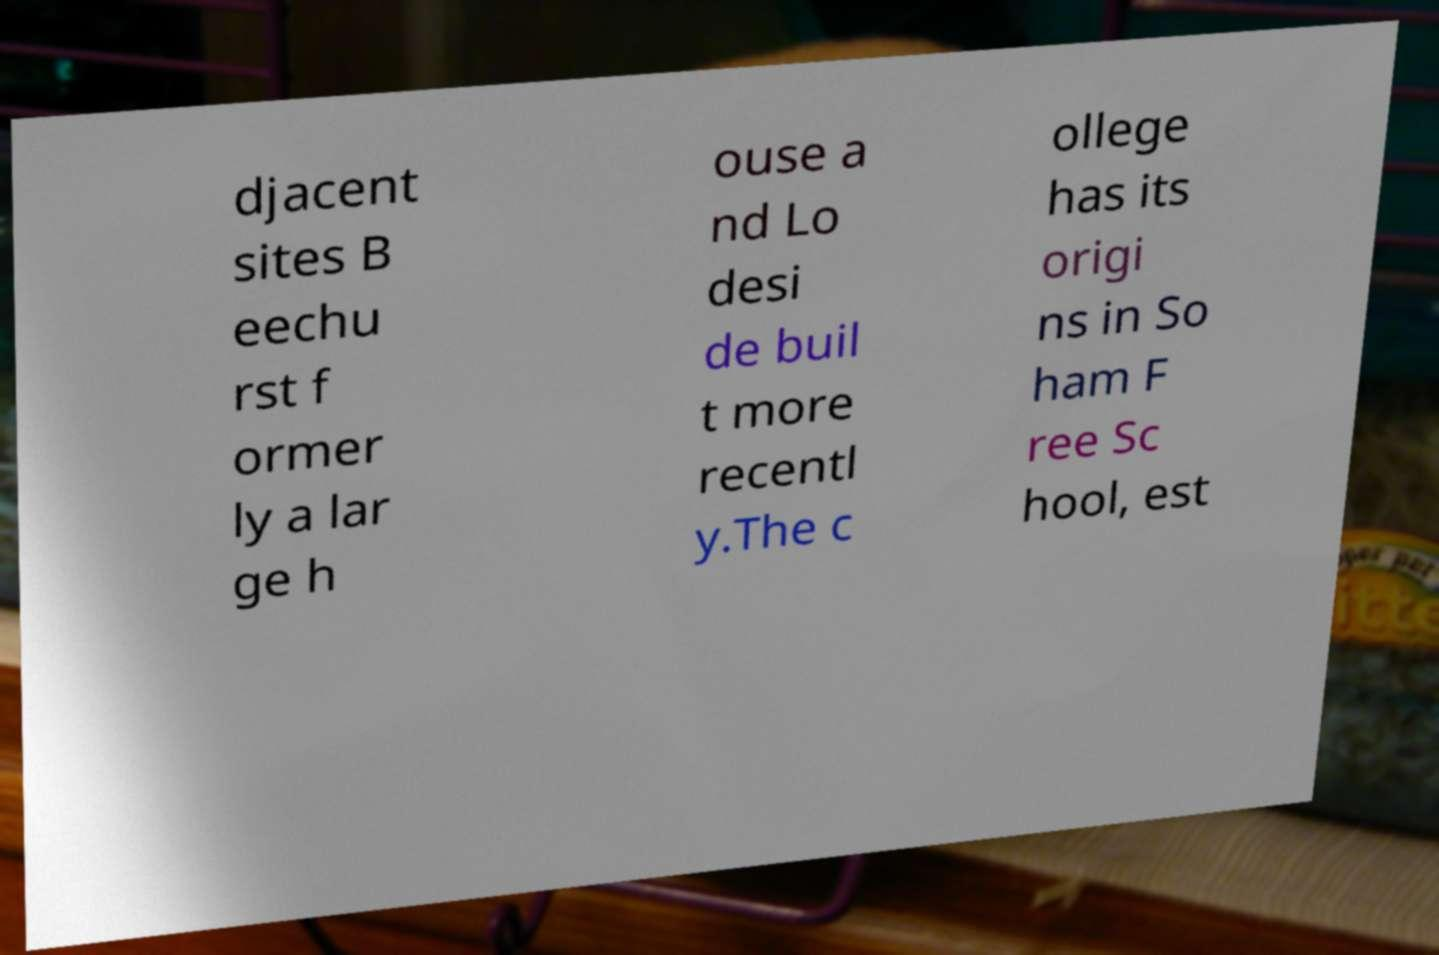Can you accurately transcribe the text from the provided image for me? djacent sites B eechu rst f ormer ly a lar ge h ouse a nd Lo desi de buil t more recentl y.The c ollege has its origi ns in So ham F ree Sc hool, est 